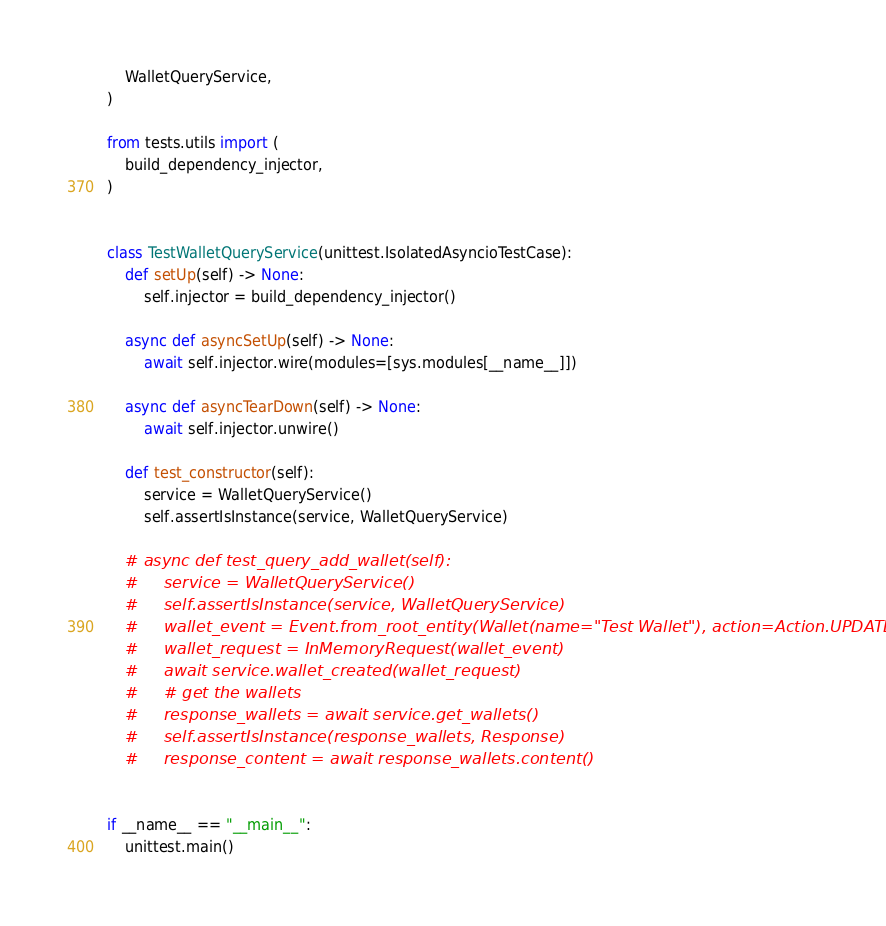<code> <loc_0><loc_0><loc_500><loc_500><_Python_>    WalletQueryService,
)

from tests.utils import (
    build_dependency_injector,
)


class TestWalletQueryService(unittest.IsolatedAsyncioTestCase):
    def setUp(self) -> None:
        self.injector = build_dependency_injector()

    async def asyncSetUp(self) -> None:
        await self.injector.wire(modules=[sys.modules[__name__]])

    async def asyncTearDown(self) -> None:
        await self.injector.unwire()

    def test_constructor(self):
        service = WalletQueryService()
        self.assertIsInstance(service, WalletQueryService)

    # async def test_query_add_wallet(self):
    #     service = WalletQueryService()
    #     self.assertIsInstance(service, WalletQueryService)
    #     wallet_event = Event.from_root_entity(Wallet(name="Test Wallet"), action=Action.UPDATE)
    #     wallet_request = InMemoryRequest(wallet_event)
    #     await service.wallet_created(wallet_request)
    #     # get the wallets
    #     response_wallets = await service.get_wallets()
    #     self.assertIsInstance(response_wallets, Response)
    #     response_content = await response_wallets.content()


if __name__ == "__main__":
    unittest.main()
</code> 